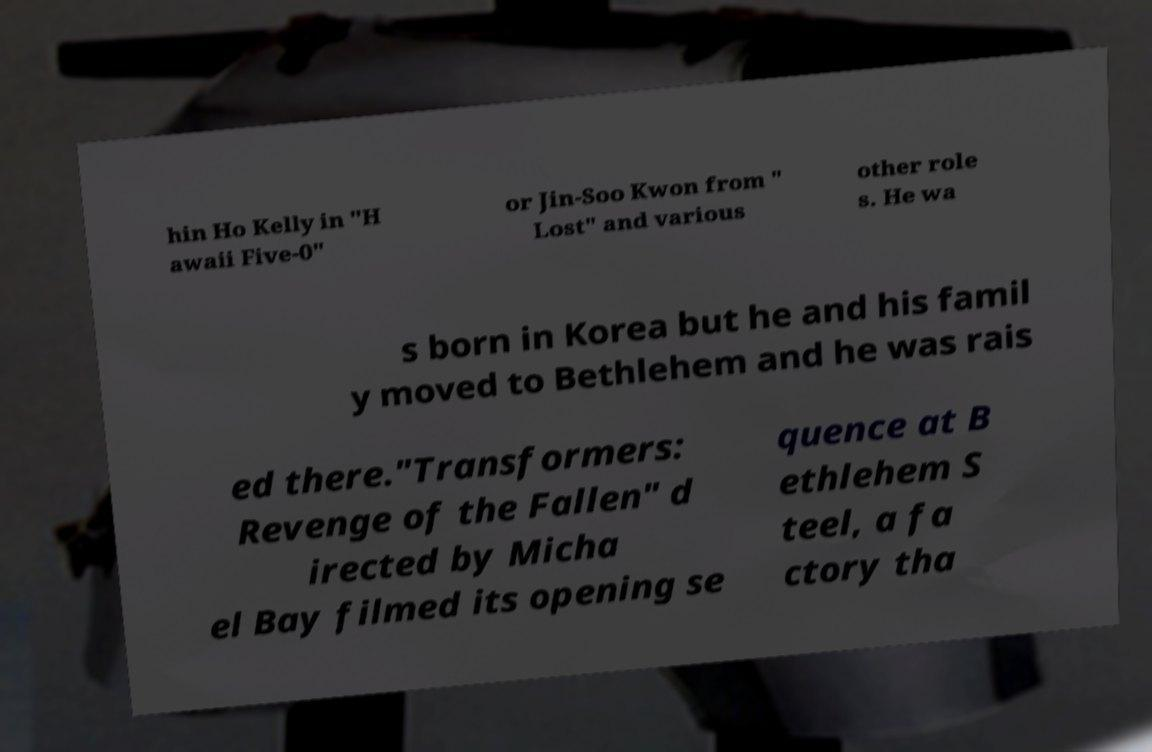Can you accurately transcribe the text from the provided image for me? hin Ho Kelly in "H awaii Five-0" or Jin-Soo Kwon from " Lost" and various other role s. He wa s born in Korea but he and his famil y moved to Bethlehem and he was rais ed there."Transformers: Revenge of the Fallen" d irected by Micha el Bay filmed its opening se quence at B ethlehem S teel, a fa ctory tha 